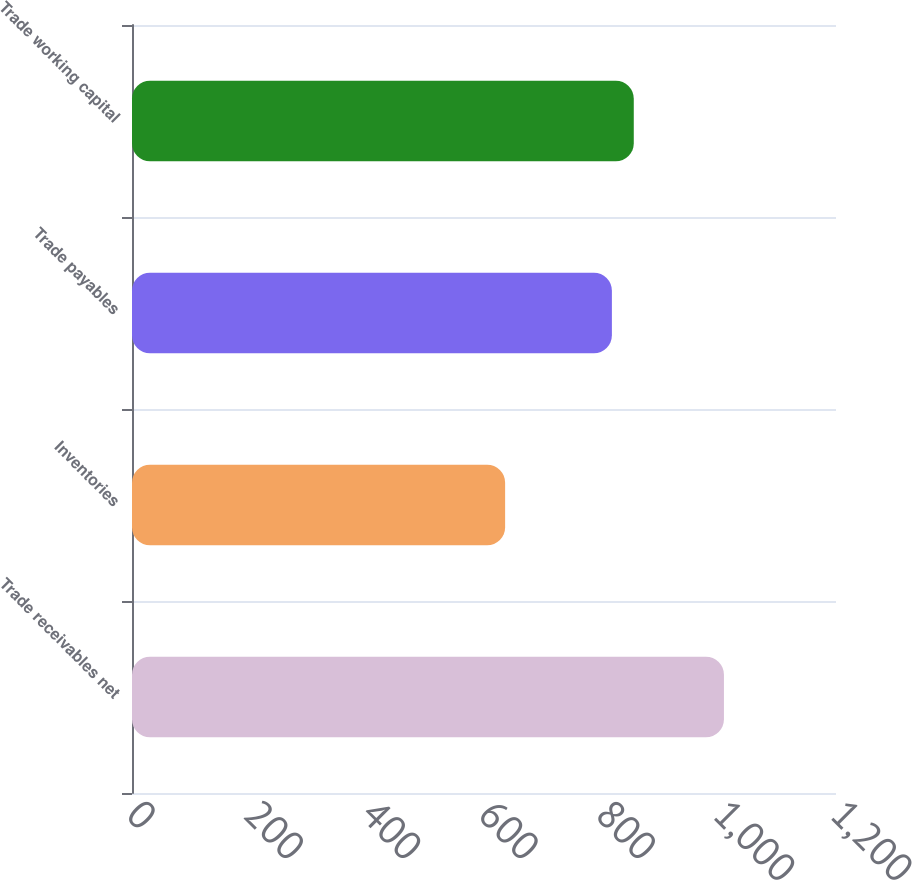<chart> <loc_0><loc_0><loc_500><loc_500><bar_chart><fcel>Trade receivables net<fcel>Inventories<fcel>Trade payables<fcel>Trade working capital<nl><fcel>1009<fcel>636<fcel>818<fcel>855.3<nl></chart> 